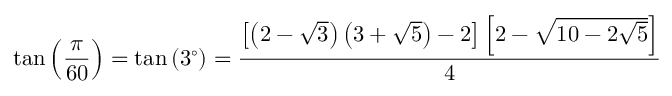Convert formula to latex. <formula><loc_0><loc_0><loc_500><loc_500>\tan \left ( { \frac { \pi } { 6 0 } } \right ) = \tan \left ( 3 ^ { \circ } \right ) = { \frac { \left [ \left ( 2 - { \sqrt { 3 } } \right ) \left ( 3 + { \sqrt { 5 } } \right ) - 2 \right ] \left [ 2 - { \sqrt { 1 0 - 2 { \sqrt { 5 } } } } \right ] } { 4 } }</formula> 